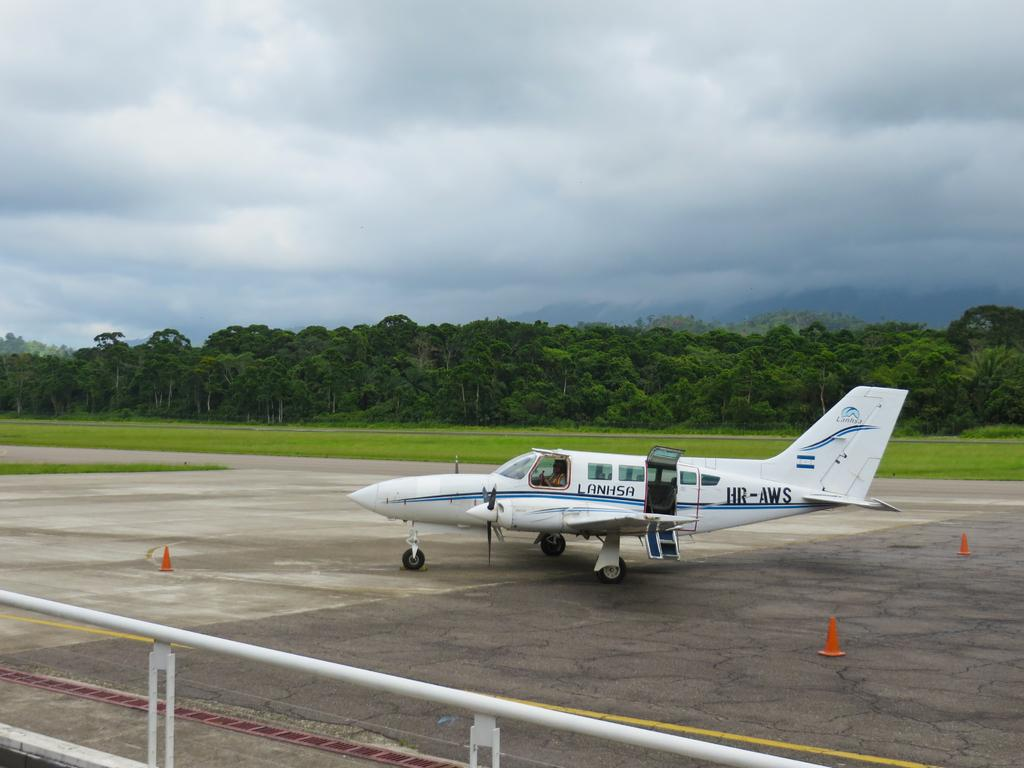<image>
Present a compact description of the photo's key features. A small airplane sitting on a runway with the text Lansha written on the side. 